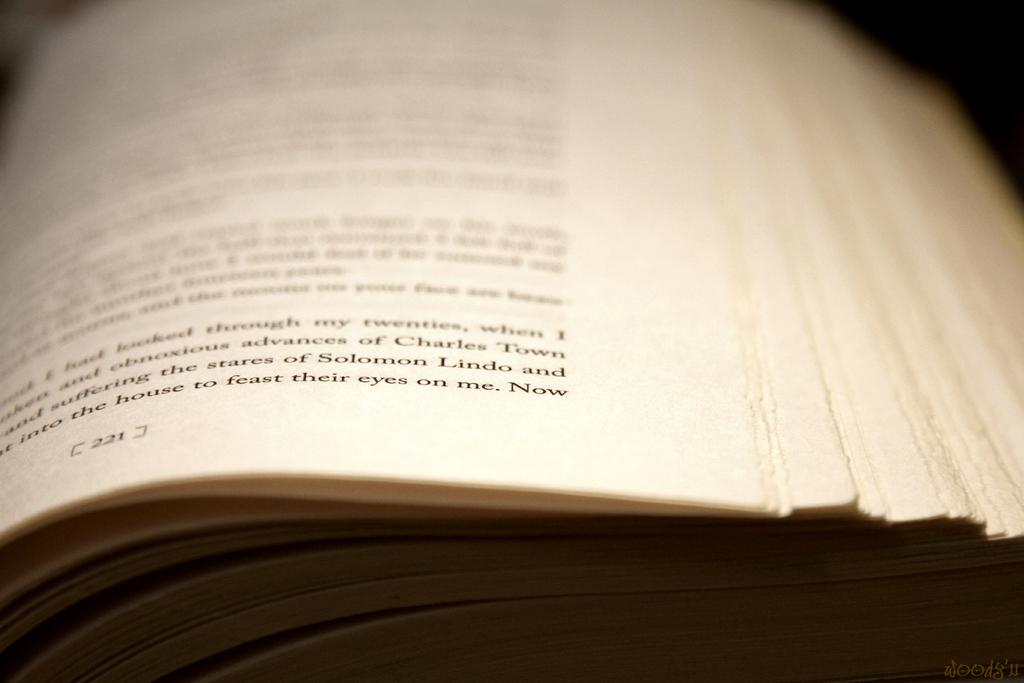<image>
Relay a brief, clear account of the picture shown. Open book on a page that has the number 221 on the bottom. 